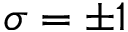Convert formula to latex. <formula><loc_0><loc_0><loc_500><loc_500>\sigma = \pm 1</formula> 